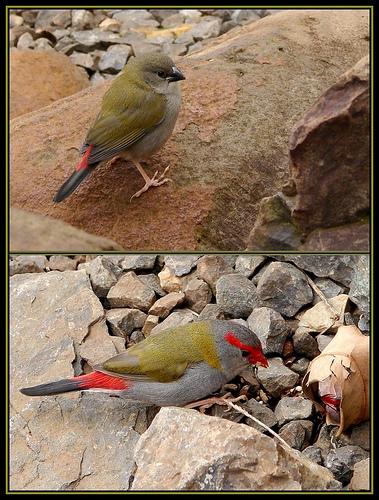What are the birds standing on?
Quick response, please. Rocks. Are these two birds the same?
Write a very short answer. No. What type of bird is this?
Answer briefly. Finch. 